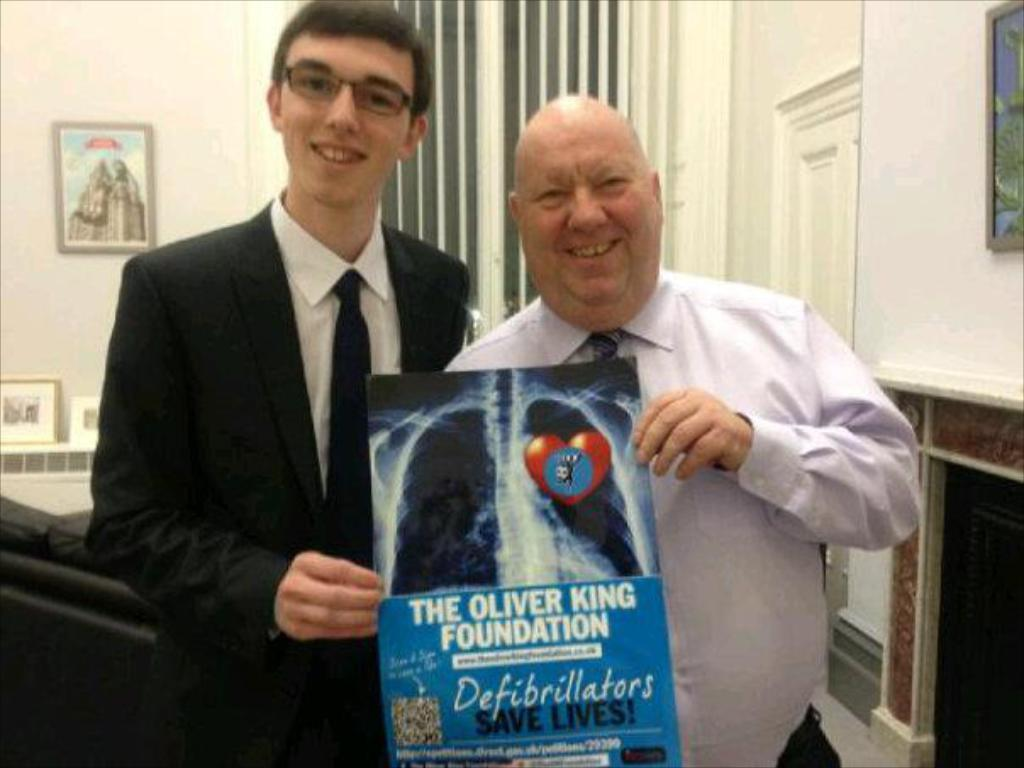What can be seen in the image? There are men standing in the image. What are the men holding in their hands? The men are holding an x-ray sheet in their hands. What is visible on the wall in the background of the image? There is a photo frame on the wall in the background of the image. What type of pie is being served to the men in the image? There is no pie present in the image; the men are holding an x-ray sheet. 